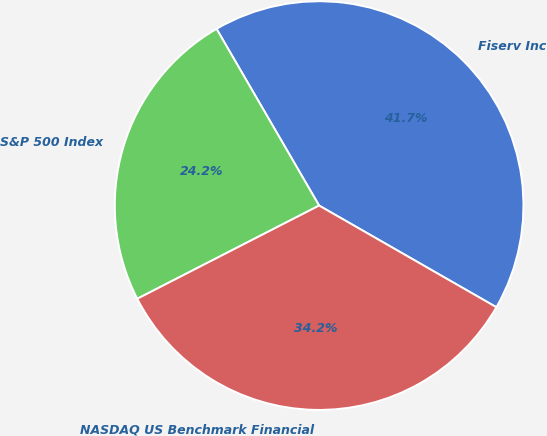<chart> <loc_0><loc_0><loc_500><loc_500><pie_chart><fcel>Fiserv Inc<fcel>S&P 500 Index<fcel>NASDAQ US Benchmark Financial<nl><fcel>41.66%<fcel>24.17%<fcel>34.18%<nl></chart> 